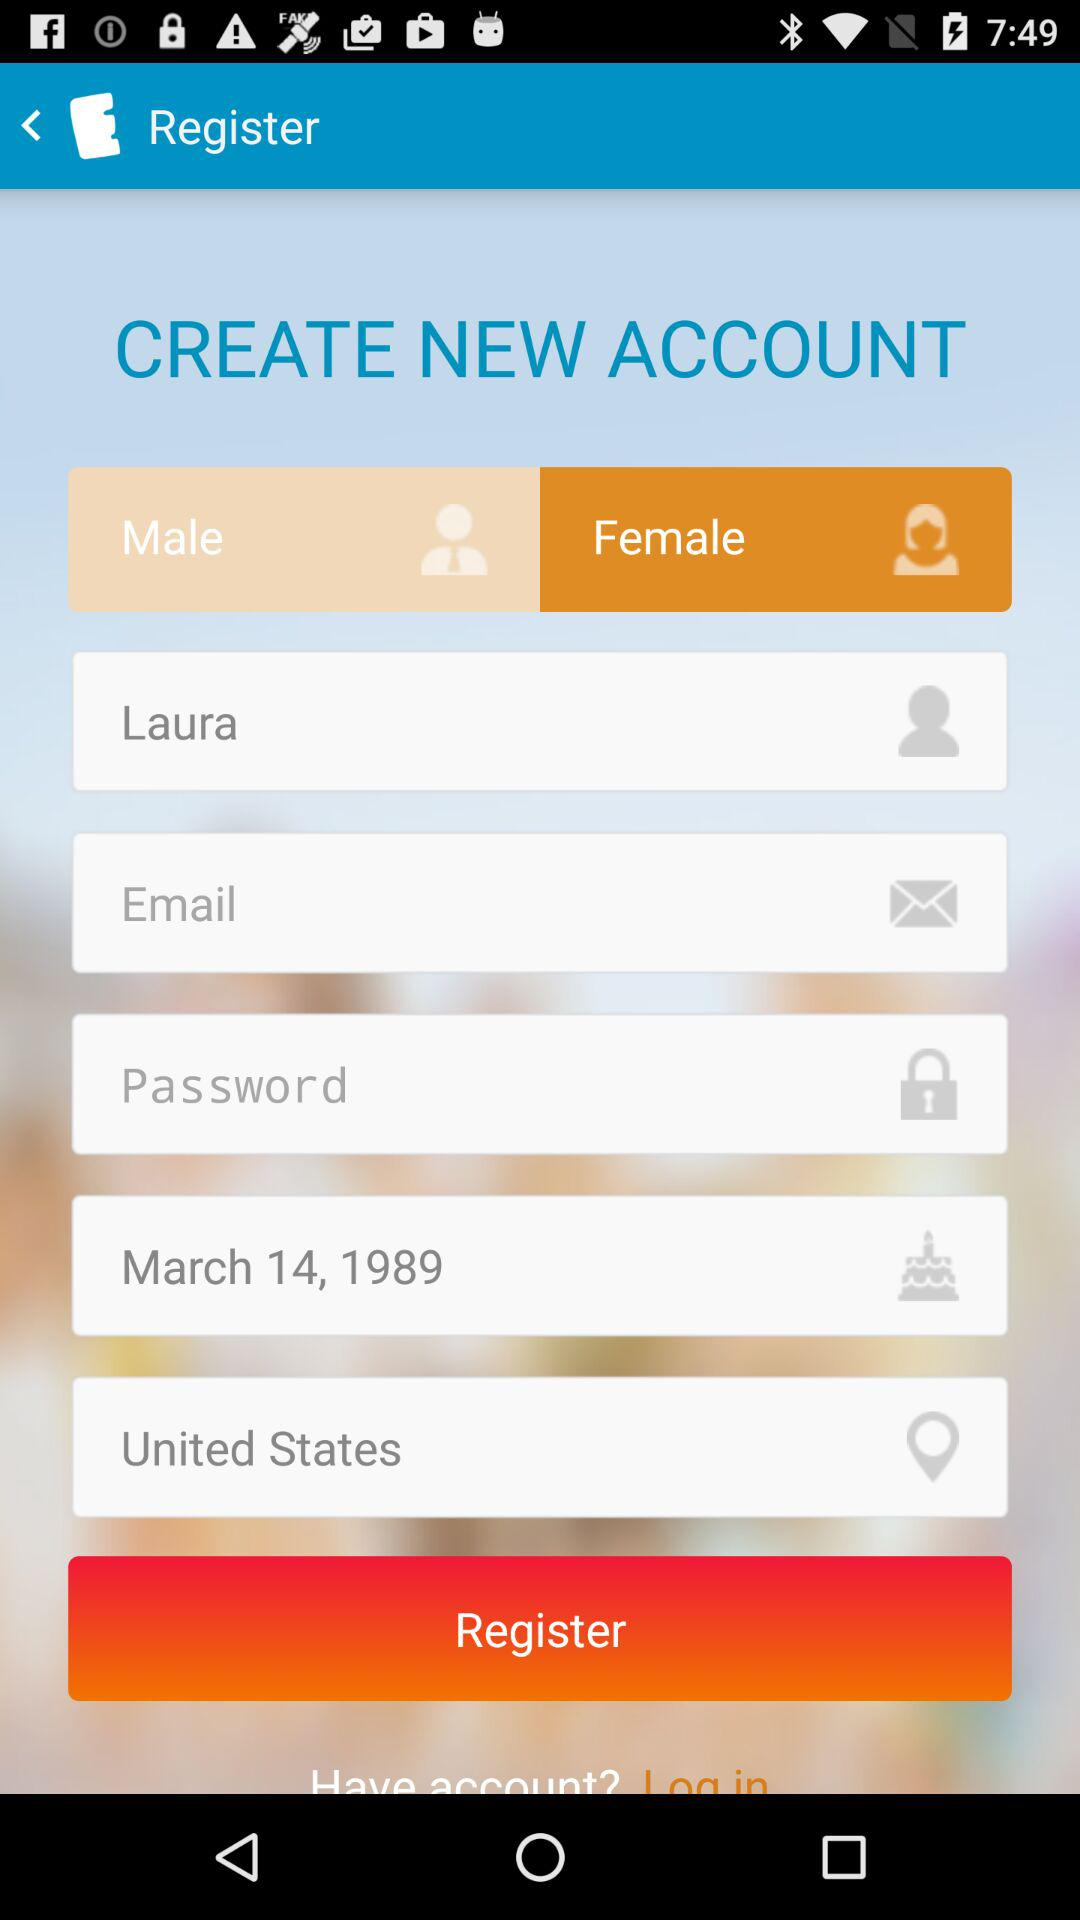Which country has been mentioned? The country that has been mentioned is the United States. 